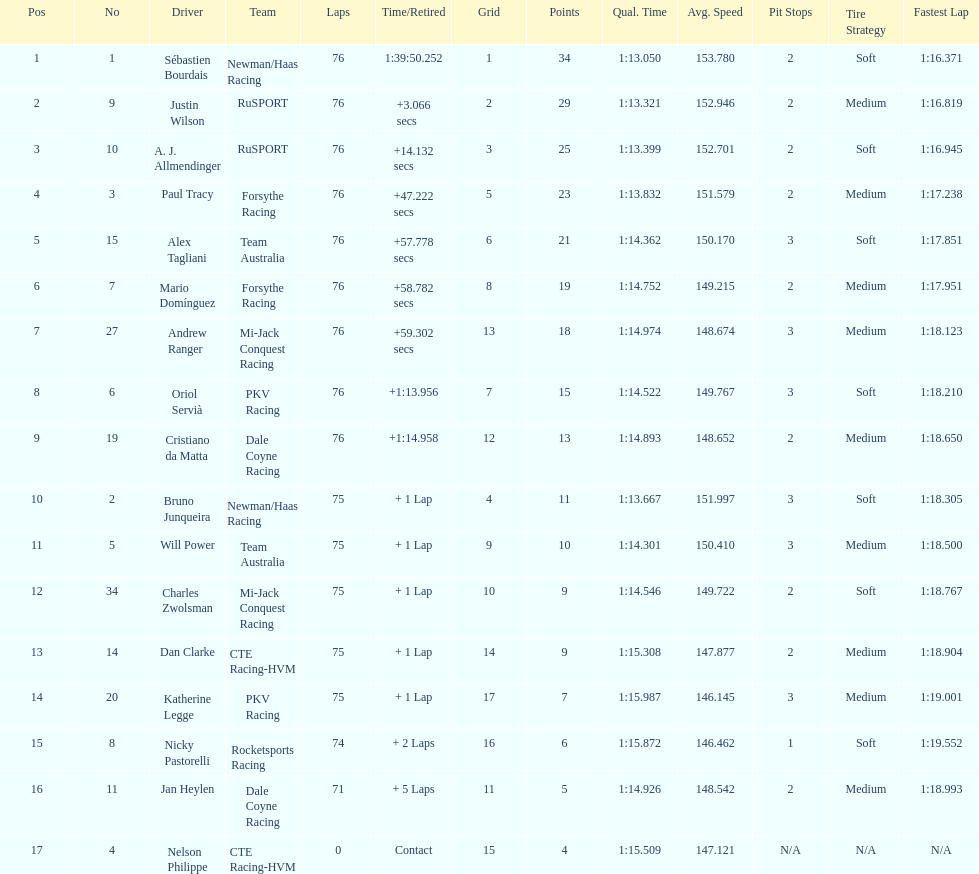How many drivers were competing for brazil? 2. 